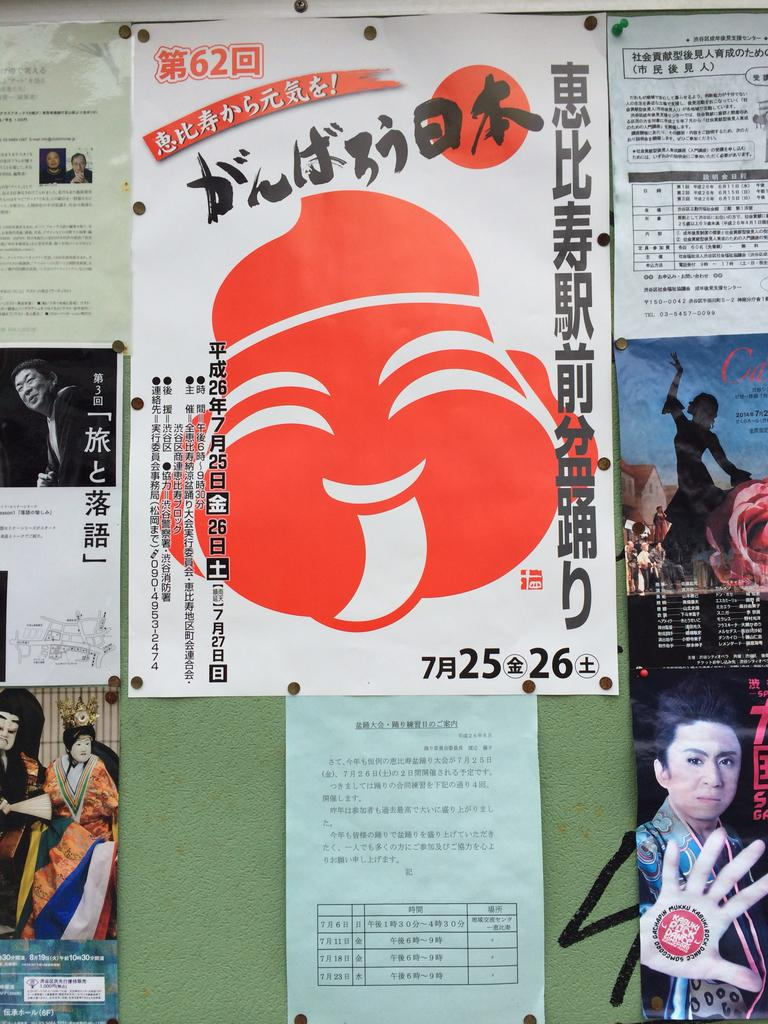What can be seen on the posters in the image? There are posters in the image, and they have text written on them. Are there any images on the posters? Yes, there are images of persons on the posters. What else can be seen in the image besides the posters? There are pins visible in the image. What type of soap is being advertised on the posters in the image? There is no soap being advertised on the posters in the image; the posters contain images of persons and text. 